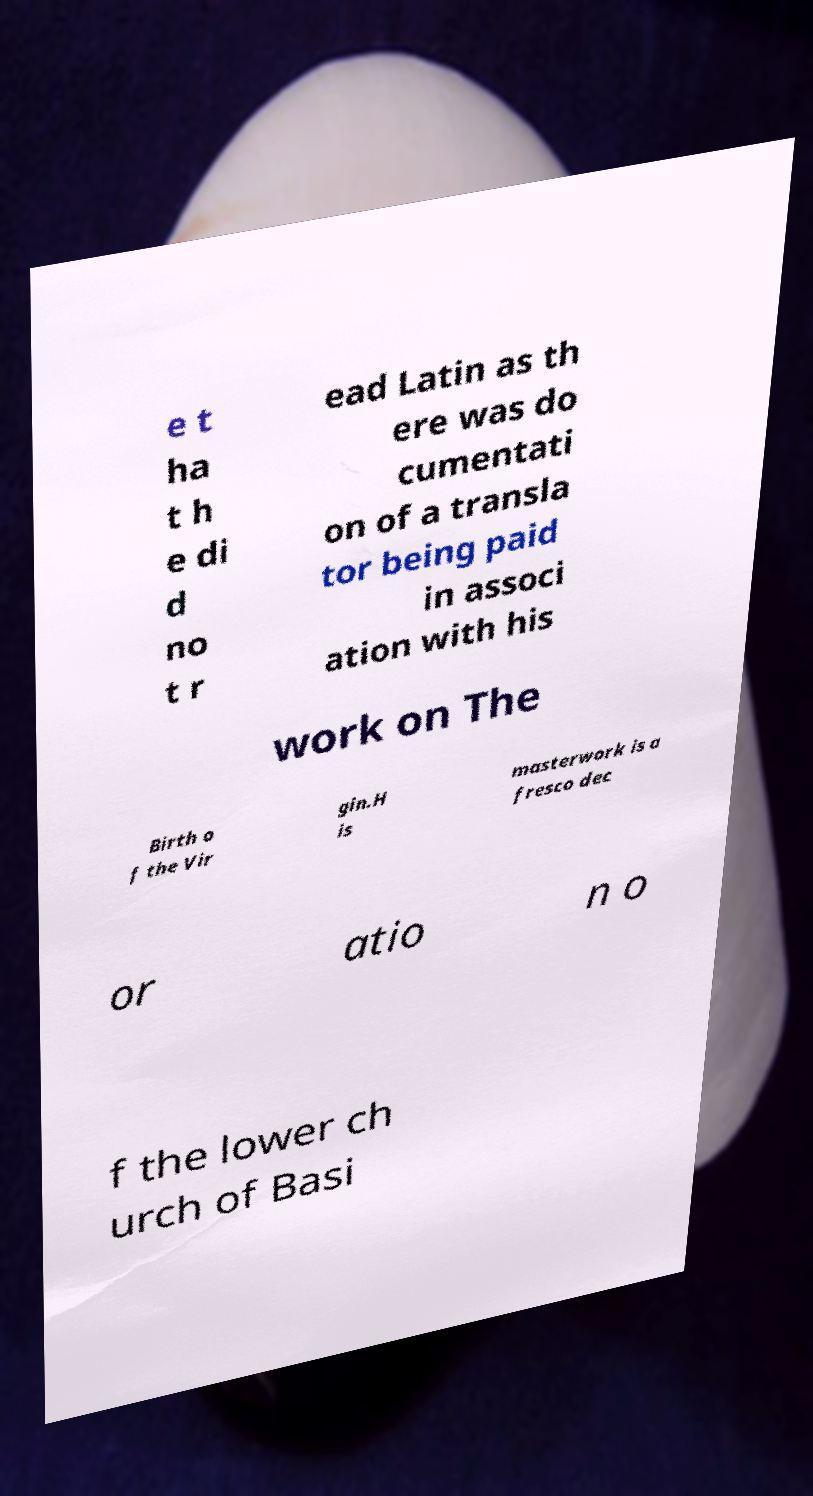Could you extract and type out the text from this image? e t ha t h e di d no t r ead Latin as th ere was do cumentati on of a transla tor being paid in associ ation with his work on The Birth o f the Vir gin.H is masterwork is a fresco dec or atio n o f the lower ch urch of Basi 